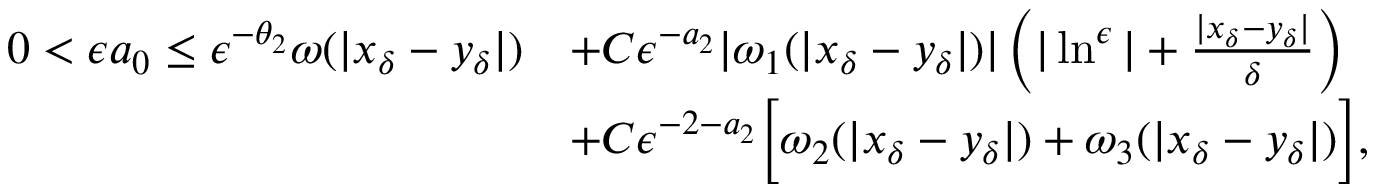Convert formula to latex. <formula><loc_0><loc_0><loc_500><loc_500>\begin{array} { r l } { 0 < \epsilon a _ { 0 } \leq \epsilon ^ { - \theta _ { 2 } } \omega ( | x _ { \delta } - y _ { \delta } | ) } & { + C \epsilon ^ { - a _ { 2 } } | \omega _ { 1 } ( | x _ { \delta } - y _ { \delta } | ) | \left ( | \ln ^ { \epsilon } | + \frac { | x _ { \delta } - y _ { \delta } | } { \delta } \right ) } \\ & { + C \epsilon ^ { - 2 - a _ { 2 } } \left [ \omega _ { 2 } ( | x _ { \delta } - y _ { \delta } | ) + \omega _ { 3 } ( | x _ { \delta } - y _ { \delta } | ) \right ] , } \end{array}</formula> 